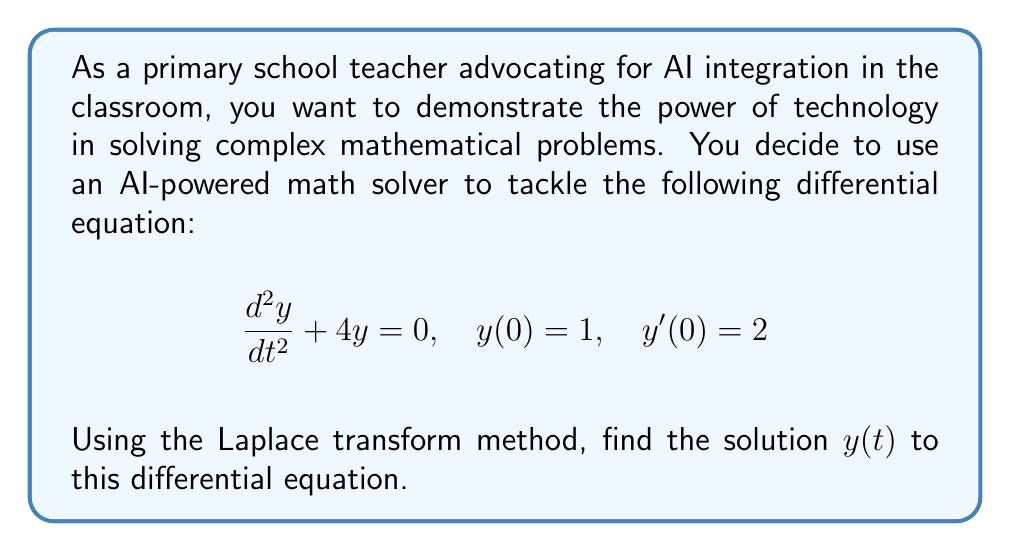Help me with this question. Let's solve this step-by-step using the Laplace transform method:

1) First, we take the Laplace transform of both sides of the equation. Let $Y(s) = \mathcal{L}\{y(t)\}$.

   $$\mathcal{L}\{\frac{d^2y}{dt^2} + 4y\} = \mathcal{L}\{0\}$$

2) Using the properties of Laplace transforms:

   $$s^2Y(s) - sy(0) - y'(0) + 4Y(s) = 0$$

3) Substitute the initial conditions $y(0) = 1$ and $y'(0) = 2$:

   $$s^2Y(s) - s - 2 + 4Y(s) = 0$$

4) Rearrange the equation:

   $$(s^2 + 4)Y(s) = s + 2$$

5) Solve for $Y(s)$:

   $$Y(s) = \frac{s + 2}{s^2 + 4}$$

6) This can be rewritten as:

   $$Y(s) = \frac{s}{s^2 + 4} + \frac{2}{s^2 + 4}$$

7) We recognize these as standard Laplace transform pairs:

   $$\mathcal{L}^{-1}\{\frac{s}{s^2 + a^2}\} = \cos(at)$$
   $$\mathcal{L}^{-1}\{\frac{a}{s^2 + a^2}\} = \sin(at)$$

8) Therefore, taking the inverse Laplace transform:

   $$y(t) = \cos(2t) + \sin(2t)$$

This is the solution to the differential equation.
Answer: $y(t) = \cos(2t) + \sin(2t)$ 